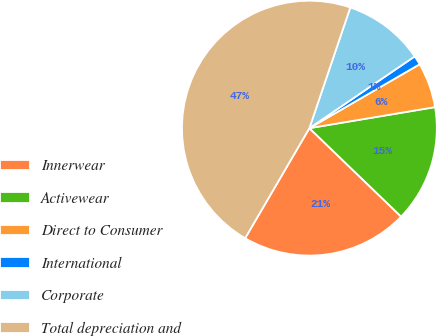Convert chart to OTSL. <chart><loc_0><loc_0><loc_500><loc_500><pie_chart><fcel>Innerwear<fcel>Activewear<fcel>Direct to Consumer<fcel>International<fcel>Corporate<fcel>Total depreciation and<nl><fcel>21.2%<fcel>14.85%<fcel>5.72%<fcel>1.16%<fcel>10.28%<fcel>46.79%<nl></chart> 